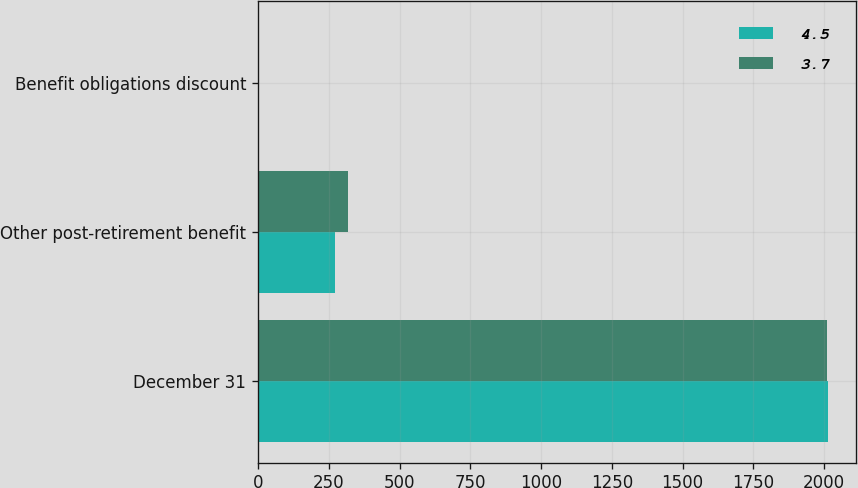<chart> <loc_0><loc_0><loc_500><loc_500><stacked_bar_chart><ecel><fcel>December 31<fcel>Other post-retirement benefit<fcel>Benefit obligations discount<nl><fcel>4.5<fcel>2013<fcel>270.9<fcel>4.5<nl><fcel>3.7<fcel>2012<fcel>318.4<fcel>3.7<nl></chart> 